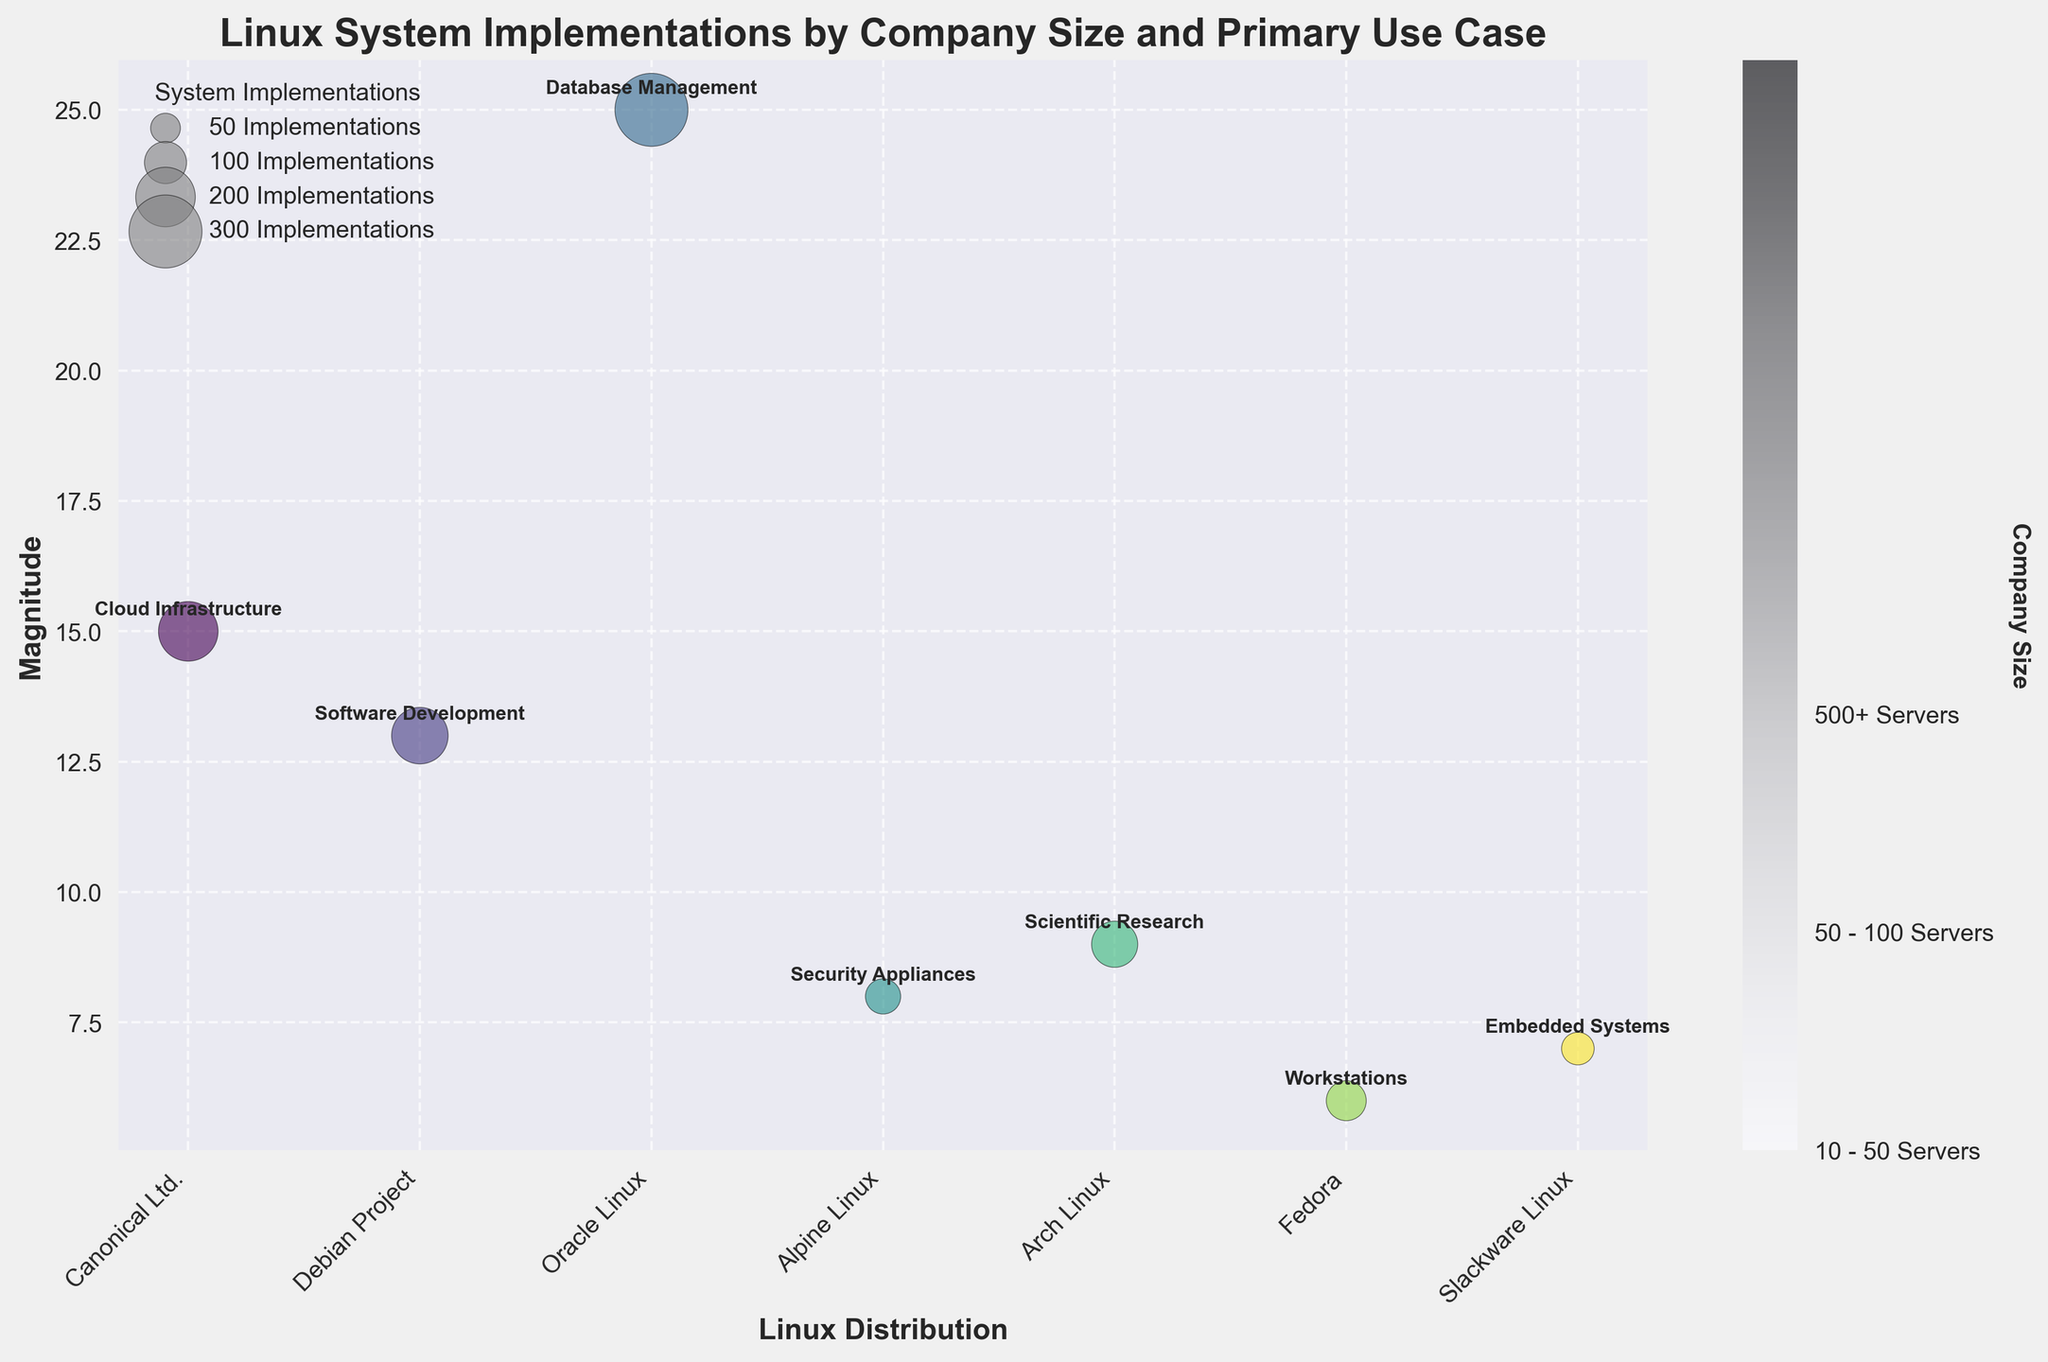How many different companies are represented in the bubble chart? The x-axis of the chart displays the Linux distributions, representing distinct companies. By counting the labels on the x-axis, we can see that there are seven different companies.
Answer: Seven Which company has the largest "System Implementations" and what is its primary use case? The size of the bubbles indicates the number of system implementations. The largest bubble corresponds to Oracle Linux, with 300 implementations. The annotation shows its primary use case is Database Management.
Answer: Oracle Linux, Database Management Compare the magnitude for Canonical Ltd. and Debian Project. Which company has a higher value, and by how much? The y-axis represents the magnitude. Canonical Ltd. has a magnitude of 15, while Debian Project has a magnitude of 13. The difference is 15 - 13 = 2.
Answer: Canonical Ltd., 2 What primary use case is associated with Arch Linux, and what is its company size? The annotation near the Arch Linux bubble on the chart indicates its primary use case. The color bar represents the company size. Arch Linux is used for Scientific Research and the color indicates a size range of 50 - 100 Servers.
Answer: Scientific Research, 50 - 100 Servers Which two companies have the smallest system implementations and what are their primary use cases? The bubbles with the smallest sizes belong to Slackware Linux and Alpine Linux. Slackware Linux is for Embedded Systems with 60 implementations and Alpine Linux is for Security Appliances with 70 implementations.
Answer: Slackware Linux (Embedded Systems), Alpine Linux (Security Appliances) What is the average number of system implementations for all companies? Sum the system implementations for all companies and divide by the number of companies. The sum is 200 + 180 + 300 + 70 + 120 + 90 + 60 = 1020. Dividing by 7 companies, the average is 1020 / 7 ≈ 145.7.
Answer: Approximately 145.7 Which company with the size range "10 - 50 Servers" has the highest magnitude? From the color bar, identify companies in the size range "10 - 50 Servers." Compare their magnitudes from the y-axis. Slackware Linux (7) and Alpine Linux (8) fit this range, with Alpine Linux having the higher magnitude.
Answer: Alpine Linux How are the companies categorized in the legend for system implementations? The legend represents different sizes (50, 100, 200, 300) by varying the bubble size. These sizes categorize the companies based on their system implementations.
Answer: By bubble size Which company is used for "Cloud Infrastructure" and how many implementations does it have? The annotation near the corresponding bubble indicates the primary use case. Look for "Cloud Infrastructure." Canonical Ltd. is used for this purpose and has 200 implementations, as shown by the bubble size.
Answer: Canonical Ltd., 200 